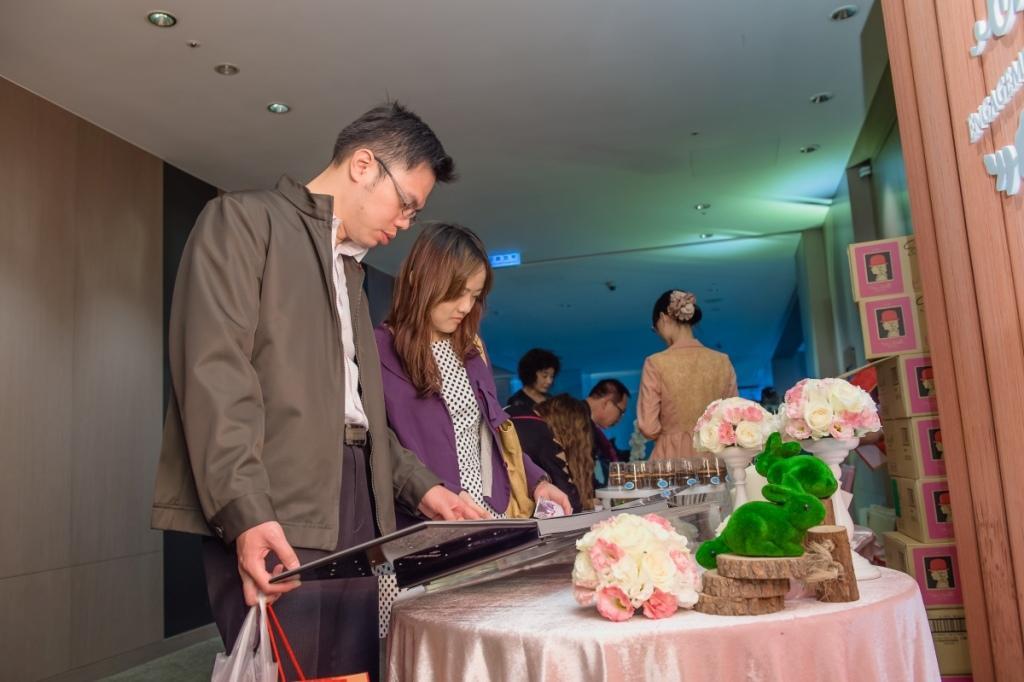How would you summarize this image in a sentence or two? In this image, we can see people and some are holding objects and bags and we can see some vases, toys, a book and some other objects on the tables. In the background, there are boxes and we can see some text on the board and there are lights and there is a wall. 